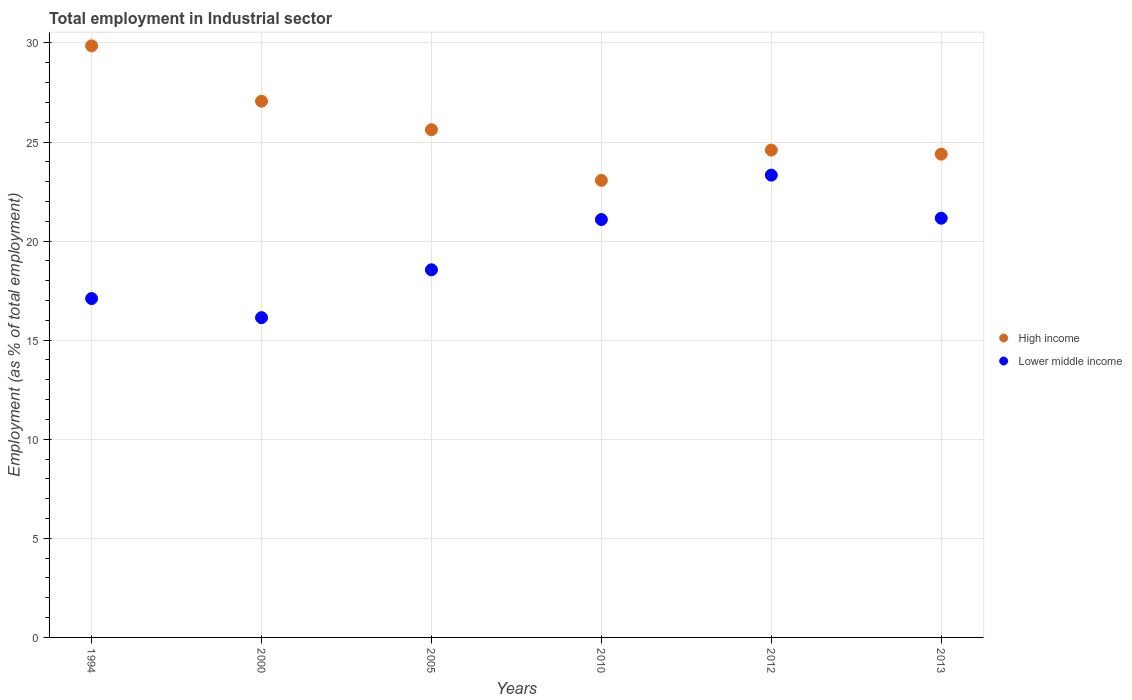What is the employment in industrial sector in Lower middle income in 2000?
Your response must be concise. 16.14. Across all years, what is the maximum employment in industrial sector in High income?
Your answer should be compact. 29.85. Across all years, what is the minimum employment in industrial sector in Lower middle income?
Offer a very short reply. 16.14. In which year was the employment in industrial sector in High income maximum?
Give a very brief answer. 1994. In which year was the employment in industrial sector in Lower middle income minimum?
Offer a very short reply. 2000. What is the total employment in industrial sector in High income in the graph?
Provide a short and direct response. 154.58. What is the difference between the employment in industrial sector in Lower middle income in 1994 and that in 2012?
Offer a terse response. -6.23. What is the difference between the employment in industrial sector in High income in 2005 and the employment in industrial sector in Lower middle income in 2012?
Make the answer very short. 2.29. What is the average employment in industrial sector in Lower middle income per year?
Your answer should be very brief. 19.56. In the year 1994, what is the difference between the employment in industrial sector in High income and employment in industrial sector in Lower middle income?
Give a very brief answer. 12.75. What is the ratio of the employment in industrial sector in Lower middle income in 1994 to that in 2010?
Ensure brevity in your answer.  0.81. What is the difference between the highest and the second highest employment in industrial sector in High income?
Your response must be concise. 2.79. What is the difference between the highest and the lowest employment in industrial sector in High income?
Give a very brief answer. 6.79. In how many years, is the employment in industrial sector in Lower middle income greater than the average employment in industrial sector in Lower middle income taken over all years?
Provide a succinct answer. 3. Is the sum of the employment in industrial sector in Lower middle income in 2005 and 2010 greater than the maximum employment in industrial sector in High income across all years?
Provide a succinct answer. Yes. How many years are there in the graph?
Give a very brief answer. 6. Does the graph contain any zero values?
Offer a very short reply. No. Does the graph contain grids?
Provide a succinct answer. Yes. How many legend labels are there?
Offer a terse response. 2. How are the legend labels stacked?
Give a very brief answer. Vertical. What is the title of the graph?
Give a very brief answer. Total employment in Industrial sector. What is the label or title of the X-axis?
Ensure brevity in your answer.  Years. What is the label or title of the Y-axis?
Make the answer very short. Employment (as % of total employment). What is the Employment (as % of total employment) of High income in 1994?
Offer a very short reply. 29.85. What is the Employment (as % of total employment) in Lower middle income in 1994?
Provide a short and direct response. 17.1. What is the Employment (as % of total employment) of High income in 2000?
Offer a terse response. 27.06. What is the Employment (as % of total employment) of Lower middle income in 2000?
Make the answer very short. 16.14. What is the Employment (as % of total employment) of High income in 2005?
Offer a very short reply. 25.62. What is the Employment (as % of total employment) of Lower middle income in 2005?
Provide a short and direct response. 18.55. What is the Employment (as % of total employment) in High income in 2010?
Your answer should be very brief. 23.06. What is the Employment (as % of total employment) in Lower middle income in 2010?
Offer a terse response. 21.09. What is the Employment (as % of total employment) in High income in 2012?
Give a very brief answer. 24.59. What is the Employment (as % of total employment) in Lower middle income in 2012?
Give a very brief answer. 23.33. What is the Employment (as % of total employment) in High income in 2013?
Give a very brief answer. 24.39. What is the Employment (as % of total employment) of Lower middle income in 2013?
Offer a terse response. 21.15. Across all years, what is the maximum Employment (as % of total employment) in High income?
Make the answer very short. 29.85. Across all years, what is the maximum Employment (as % of total employment) of Lower middle income?
Offer a very short reply. 23.33. Across all years, what is the minimum Employment (as % of total employment) in High income?
Provide a short and direct response. 23.06. Across all years, what is the minimum Employment (as % of total employment) of Lower middle income?
Offer a terse response. 16.14. What is the total Employment (as % of total employment) of High income in the graph?
Provide a succinct answer. 154.58. What is the total Employment (as % of total employment) of Lower middle income in the graph?
Keep it short and to the point. 117.36. What is the difference between the Employment (as % of total employment) in High income in 1994 and that in 2000?
Keep it short and to the point. 2.79. What is the difference between the Employment (as % of total employment) in Lower middle income in 1994 and that in 2000?
Your response must be concise. 0.96. What is the difference between the Employment (as % of total employment) of High income in 1994 and that in 2005?
Provide a short and direct response. 4.23. What is the difference between the Employment (as % of total employment) in Lower middle income in 1994 and that in 2005?
Make the answer very short. -1.45. What is the difference between the Employment (as % of total employment) in High income in 1994 and that in 2010?
Ensure brevity in your answer.  6.79. What is the difference between the Employment (as % of total employment) in Lower middle income in 1994 and that in 2010?
Provide a short and direct response. -3.99. What is the difference between the Employment (as % of total employment) in High income in 1994 and that in 2012?
Give a very brief answer. 5.26. What is the difference between the Employment (as % of total employment) in Lower middle income in 1994 and that in 2012?
Keep it short and to the point. -6.23. What is the difference between the Employment (as % of total employment) of High income in 1994 and that in 2013?
Provide a succinct answer. 5.47. What is the difference between the Employment (as % of total employment) of Lower middle income in 1994 and that in 2013?
Offer a terse response. -4.05. What is the difference between the Employment (as % of total employment) in High income in 2000 and that in 2005?
Ensure brevity in your answer.  1.44. What is the difference between the Employment (as % of total employment) in Lower middle income in 2000 and that in 2005?
Your answer should be compact. -2.41. What is the difference between the Employment (as % of total employment) of High income in 2000 and that in 2010?
Your answer should be compact. 4. What is the difference between the Employment (as % of total employment) in Lower middle income in 2000 and that in 2010?
Provide a succinct answer. -4.95. What is the difference between the Employment (as % of total employment) of High income in 2000 and that in 2012?
Your response must be concise. 2.47. What is the difference between the Employment (as % of total employment) in Lower middle income in 2000 and that in 2012?
Your response must be concise. -7.19. What is the difference between the Employment (as % of total employment) in High income in 2000 and that in 2013?
Keep it short and to the point. 2.67. What is the difference between the Employment (as % of total employment) in Lower middle income in 2000 and that in 2013?
Offer a very short reply. -5.02. What is the difference between the Employment (as % of total employment) in High income in 2005 and that in 2010?
Your answer should be compact. 2.56. What is the difference between the Employment (as % of total employment) in Lower middle income in 2005 and that in 2010?
Your answer should be compact. -2.54. What is the difference between the Employment (as % of total employment) in High income in 2005 and that in 2012?
Keep it short and to the point. 1.03. What is the difference between the Employment (as % of total employment) in Lower middle income in 2005 and that in 2012?
Make the answer very short. -4.78. What is the difference between the Employment (as % of total employment) of High income in 2005 and that in 2013?
Your answer should be compact. 1.23. What is the difference between the Employment (as % of total employment) of Lower middle income in 2005 and that in 2013?
Offer a very short reply. -2.6. What is the difference between the Employment (as % of total employment) of High income in 2010 and that in 2012?
Provide a succinct answer. -1.53. What is the difference between the Employment (as % of total employment) in Lower middle income in 2010 and that in 2012?
Make the answer very short. -2.24. What is the difference between the Employment (as % of total employment) in High income in 2010 and that in 2013?
Offer a terse response. -1.32. What is the difference between the Employment (as % of total employment) of Lower middle income in 2010 and that in 2013?
Your response must be concise. -0.07. What is the difference between the Employment (as % of total employment) of High income in 2012 and that in 2013?
Make the answer very short. 0.2. What is the difference between the Employment (as % of total employment) in Lower middle income in 2012 and that in 2013?
Make the answer very short. 2.17. What is the difference between the Employment (as % of total employment) of High income in 1994 and the Employment (as % of total employment) of Lower middle income in 2000?
Ensure brevity in your answer.  13.72. What is the difference between the Employment (as % of total employment) of High income in 1994 and the Employment (as % of total employment) of Lower middle income in 2005?
Give a very brief answer. 11.3. What is the difference between the Employment (as % of total employment) in High income in 1994 and the Employment (as % of total employment) in Lower middle income in 2010?
Give a very brief answer. 8.77. What is the difference between the Employment (as % of total employment) of High income in 1994 and the Employment (as % of total employment) of Lower middle income in 2012?
Ensure brevity in your answer.  6.52. What is the difference between the Employment (as % of total employment) of High income in 1994 and the Employment (as % of total employment) of Lower middle income in 2013?
Provide a succinct answer. 8.7. What is the difference between the Employment (as % of total employment) in High income in 2000 and the Employment (as % of total employment) in Lower middle income in 2005?
Offer a terse response. 8.51. What is the difference between the Employment (as % of total employment) in High income in 2000 and the Employment (as % of total employment) in Lower middle income in 2010?
Provide a short and direct response. 5.97. What is the difference between the Employment (as % of total employment) in High income in 2000 and the Employment (as % of total employment) in Lower middle income in 2012?
Give a very brief answer. 3.73. What is the difference between the Employment (as % of total employment) of High income in 2000 and the Employment (as % of total employment) of Lower middle income in 2013?
Ensure brevity in your answer.  5.91. What is the difference between the Employment (as % of total employment) of High income in 2005 and the Employment (as % of total employment) of Lower middle income in 2010?
Your answer should be very brief. 4.53. What is the difference between the Employment (as % of total employment) in High income in 2005 and the Employment (as % of total employment) in Lower middle income in 2012?
Offer a very short reply. 2.29. What is the difference between the Employment (as % of total employment) of High income in 2005 and the Employment (as % of total employment) of Lower middle income in 2013?
Give a very brief answer. 4.47. What is the difference between the Employment (as % of total employment) of High income in 2010 and the Employment (as % of total employment) of Lower middle income in 2012?
Ensure brevity in your answer.  -0.26. What is the difference between the Employment (as % of total employment) of High income in 2010 and the Employment (as % of total employment) of Lower middle income in 2013?
Offer a terse response. 1.91. What is the difference between the Employment (as % of total employment) in High income in 2012 and the Employment (as % of total employment) in Lower middle income in 2013?
Provide a succinct answer. 3.44. What is the average Employment (as % of total employment) in High income per year?
Your answer should be very brief. 25.76. What is the average Employment (as % of total employment) of Lower middle income per year?
Offer a very short reply. 19.56. In the year 1994, what is the difference between the Employment (as % of total employment) in High income and Employment (as % of total employment) in Lower middle income?
Offer a very short reply. 12.75. In the year 2000, what is the difference between the Employment (as % of total employment) of High income and Employment (as % of total employment) of Lower middle income?
Offer a very short reply. 10.92. In the year 2005, what is the difference between the Employment (as % of total employment) in High income and Employment (as % of total employment) in Lower middle income?
Make the answer very short. 7.07. In the year 2010, what is the difference between the Employment (as % of total employment) in High income and Employment (as % of total employment) in Lower middle income?
Give a very brief answer. 1.98. In the year 2012, what is the difference between the Employment (as % of total employment) of High income and Employment (as % of total employment) of Lower middle income?
Provide a short and direct response. 1.26. In the year 2013, what is the difference between the Employment (as % of total employment) in High income and Employment (as % of total employment) in Lower middle income?
Offer a very short reply. 3.23. What is the ratio of the Employment (as % of total employment) in High income in 1994 to that in 2000?
Make the answer very short. 1.1. What is the ratio of the Employment (as % of total employment) in Lower middle income in 1994 to that in 2000?
Your answer should be compact. 1.06. What is the ratio of the Employment (as % of total employment) in High income in 1994 to that in 2005?
Provide a short and direct response. 1.17. What is the ratio of the Employment (as % of total employment) of Lower middle income in 1994 to that in 2005?
Your answer should be very brief. 0.92. What is the ratio of the Employment (as % of total employment) of High income in 1994 to that in 2010?
Offer a very short reply. 1.29. What is the ratio of the Employment (as % of total employment) in Lower middle income in 1994 to that in 2010?
Provide a succinct answer. 0.81. What is the ratio of the Employment (as % of total employment) of High income in 1994 to that in 2012?
Make the answer very short. 1.21. What is the ratio of the Employment (as % of total employment) of Lower middle income in 1994 to that in 2012?
Provide a succinct answer. 0.73. What is the ratio of the Employment (as % of total employment) in High income in 1994 to that in 2013?
Make the answer very short. 1.22. What is the ratio of the Employment (as % of total employment) of Lower middle income in 1994 to that in 2013?
Provide a short and direct response. 0.81. What is the ratio of the Employment (as % of total employment) in High income in 2000 to that in 2005?
Provide a succinct answer. 1.06. What is the ratio of the Employment (as % of total employment) in Lower middle income in 2000 to that in 2005?
Give a very brief answer. 0.87. What is the ratio of the Employment (as % of total employment) in High income in 2000 to that in 2010?
Give a very brief answer. 1.17. What is the ratio of the Employment (as % of total employment) in Lower middle income in 2000 to that in 2010?
Provide a short and direct response. 0.77. What is the ratio of the Employment (as % of total employment) in High income in 2000 to that in 2012?
Your answer should be very brief. 1.1. What is the ratio of the Employment (as % of total employment) in Lower middle income in 2000 to that in 2012?
Make the answer very short. 0.69. What is the ratio of the Employment (as % of total employment) of High income in 2000 to that in 2013?
Your answer should be very brief. 1.11. What is the ratio of the Employment (as % of total employment) in Lower middle income in 2000 to that in 2013?
Offer a terse response. 0.76. What is the ratio of the Employment (as % of total employment) of High income in 2005 to that in 2010?
Your answer should be very brief. 1.11. What is the ratio of the Employment (as % of total employment) in Lower middle income in 2005 to that in 2010?
Offer a terse response. 0.88. What is the ratio of the Employment (as % of total employment) of High income in 2005 to that in 2012?
Give a very brief answer. 1.04. What is the ratio of the Employment (as % of total employment) of Lower middle income in 2005 to that in 2012?
Provide a short and direct response. 0.8. What is the ratio of the Employment (as % of total employment) of High income in 2005 to that in 2013?
Offer a terse response. 1.05. What is the ratio of the Employment (as % of total employment) of Lower middle income in 2005 to that in 2013?
Your answer should be very brief. 0.88. What is the ratio of the Employment (as % of total employment) in High income in 2010 to that in 2012?
Offer a terse response. 0.94. What is the ratio of the Employment (as % of total employment) of Lower middle income in 2010 to that in 2012?
Give a very brief answer. 0.9. What is the ratio of the Employment (as % of total employment) in High income in 2010 to that in 2013?
Offer a very short reply. 0.95. What is the ratio of the Employment (as % of total employment) in Lower middle income in 2010 to that in 2013?
Give a very brief answer. 1. What is the ratio of the Employment (as % of total employment) in High income in 2012 to that in 2013?
Keep it short and to the point. 1.01. What is the ratio of the Employment (as % of total employment) in Lower middle income in 2012 to that in 2013?
Keep it short and to the point. 1.1. What is the difference between the highest and the second highest Employment (as % of total employment) in High income?
Give a very brief answer. 2.79. What is the difference between the highest and the second highest Employment (as % of total employment) of Lower middle income?
Make the answer very short. 2.17. What is the difference between the highest and the lowest Employment (as % of total employment) in High income?
Your answer should be compact. 6.79. What is the difference between the highest and the lowest Employment (as % of total employment) of Lower middle income?
Keep it short and to the point. 7.19. 